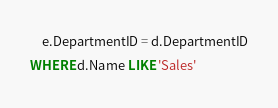<code> <loc_0><loc_0><loc_500><loc_500><_SQL_>	e.DepartmentID = d.DepartmentID
WHERE d.Name LIKE 'Sales'</code> 